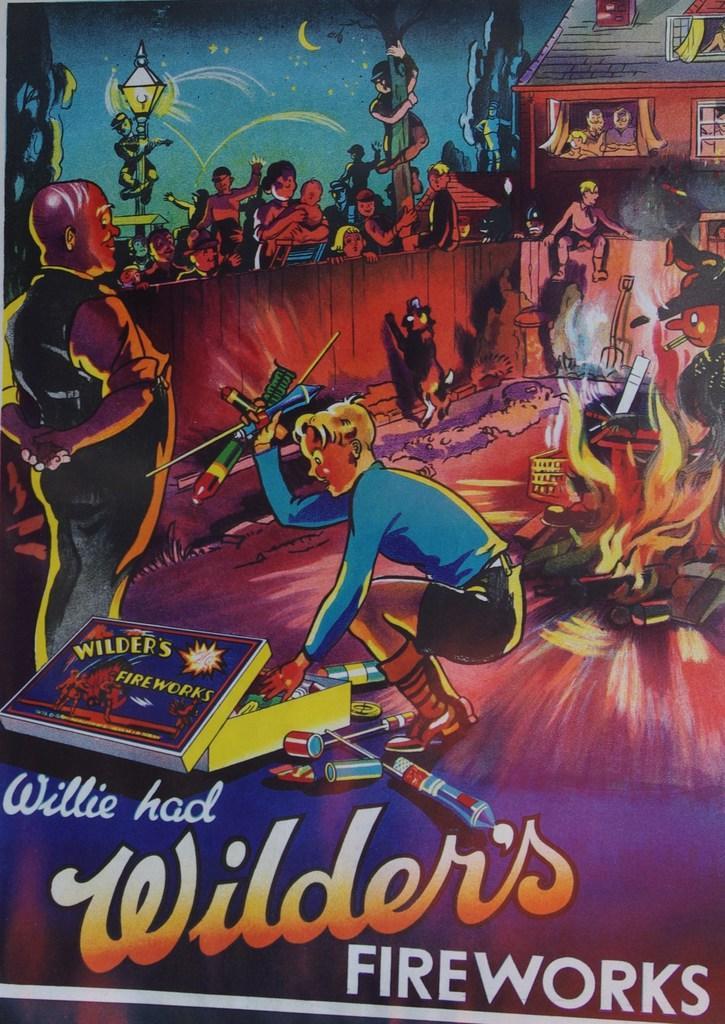Describe this image in one or two sentences. In this image we can see an advertisement. In this advertisement there are crackers and we can see people. At the top there is a shed and we can see sky. On the left there is a pole. 